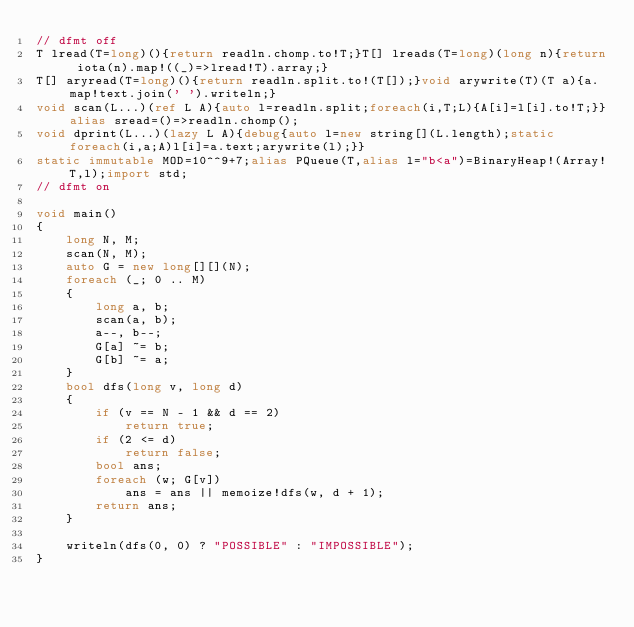Convert code to text. <code><loc_0><loc_0><loc_500><loc_500><_D_>// dfmt off
T lread(T=long)(){return readln.chomp.to!T;}T[] lreads(T=long)(long n){return iota(n).map!((_)=>lread!T).array;}
T[] aryread(T=long)(){return readln.split.to!(T[]);}void arywrite(T)(T a){a.map!text.join(' ').writeln;}
void scan(L...)(ref L A){auto l=readln.split;foreach(i,T;L){A[i]=l[i].to!T;}}alias sread=()=>readln.chomp();
void dprint(L...)(lazy L A){debug{auto l=new string[](L.length);static foreach(i,a;A)l[i]=a.text;arywrite(l);}}
static immutable MOD=10^^9+7;alias PQueue(T,alias l="b<a")=BinaryHeap!(Array!T,l);import std;
// dfmt on

void main()
{
    long N, M;
    scan(N, M);
    auto G = new long[][](N);
    foreach (_; 0 .. M)
    {
        long a, b;
        scan(a, b);
        a--, b--;
        G[a] ~= b;
        G[b] ~= a;
    }
    bool dfs(long v, long d)
    {
        if (v == N - 1 && d == 2)
            return true;
        if (2 <= d)
            return false;
        bool ans;
        foreach (w; G[v])
            ans = ans || memoize!dfs(w, d + 1);
        return ans;
    }

    writeln(dfs(0, 0) ? "POSSIBLE" : "IMPOSSIBLE");
}
</code> 